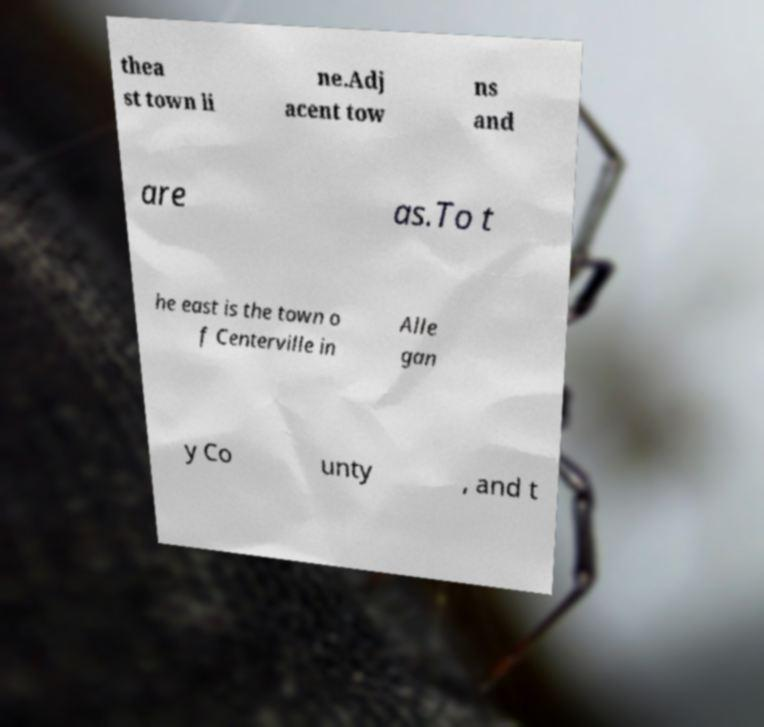Could you extract and type out the text from this image? thea st town li ne.Adj acent tow ns and are as.To t he east is the town o f Centerville in Alle gan y Co unty , and t 